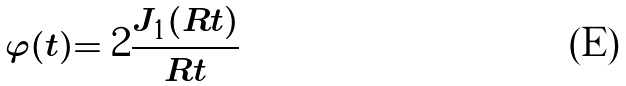Convert formula to latex. <formula><loc_0><loc_0><loc_500><loc_500>\varphi ( t ) = 2 \frac { J _ { 1 } ( R t ) } { R t }</formula> 